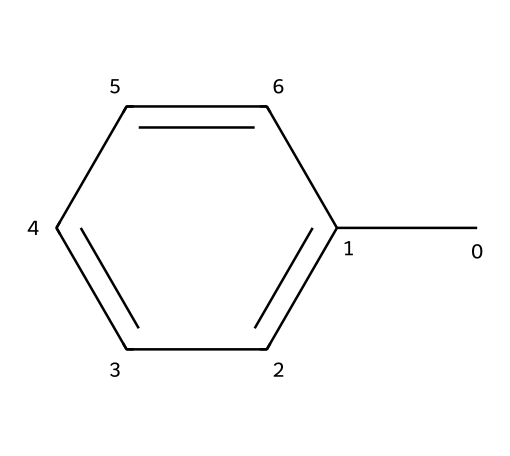What is the name of the chemical represented by this SMILES? The SMILES notation "Cc1ccccc1" corresponds to toluene, which is recognized as an aromatic compound due to its benzene ring structure with a methyl group attached.
Answer: toluene How many carbon atoms are in toluene? The SMILES structure shows that there are 7 carbon atoms in total: 6 from the benzene ring and 1 from the attached methyl group.
Answer: 7 What is the number of hydrogen atoms in toluene? Given the presence of 7 carbon atoms in toluene, and considering each carbon typically bonds to one hydrogen when in a methyl group or as part of a benzene, the total hydrogen count becomes 8 (7 from carbon and additional structural bonding).
Answer: 8 Is toluene a hazardous chemical? Toluene is classified as hazardous due to its toxic effects on the central nervous system and other concerning health effects, making it important to handle it with care.
Answer: yes What type of solvent is toluene considered? Toluene is often categorized as an aromatic solvent due to its chemical structure, which allows it to dissolve various organic compounds effectively.
Answer: aromatic What functional groups can be derived from toluene? In toluene, the primary functional group present is the aromatic ring, and if modified further, it can have other alkyl aromatics or functional transformations.
Answer: aromatic ring What is a common use of toluene in industrial settings? Toluene is frequently utilized as a solvent for paint thinners and in the production of various chemicals in the electronics cleaning industry.
Answer: solvent 